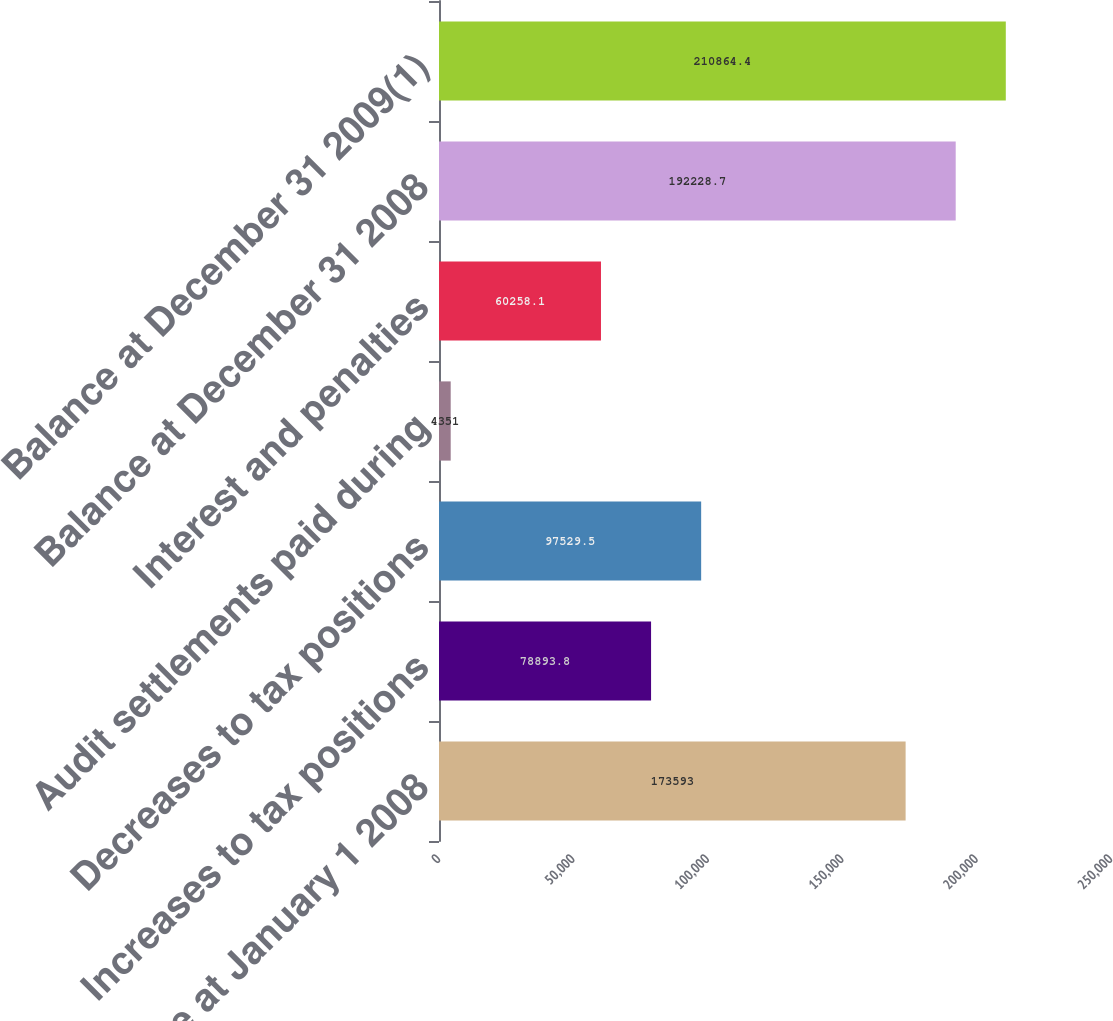<chart> <loc_0><loc_0><loc_500><loc_500><bar_chart><fcel>Balance at January 1 2008<fcel>Increases to tax positions<fcel>Decreases to tax positions<fcel>Audit settlements paid during<fcel>Interest and penalties<fcel>Balance at December 31 2008<fcel>Balance at December 31 2009(1)<nl><fcel>173593<fcel>78893.8<fcel>97529.5<fcel>4351<fcel>60258.1<fcel>192229<fcel>210864<nl></chart> 